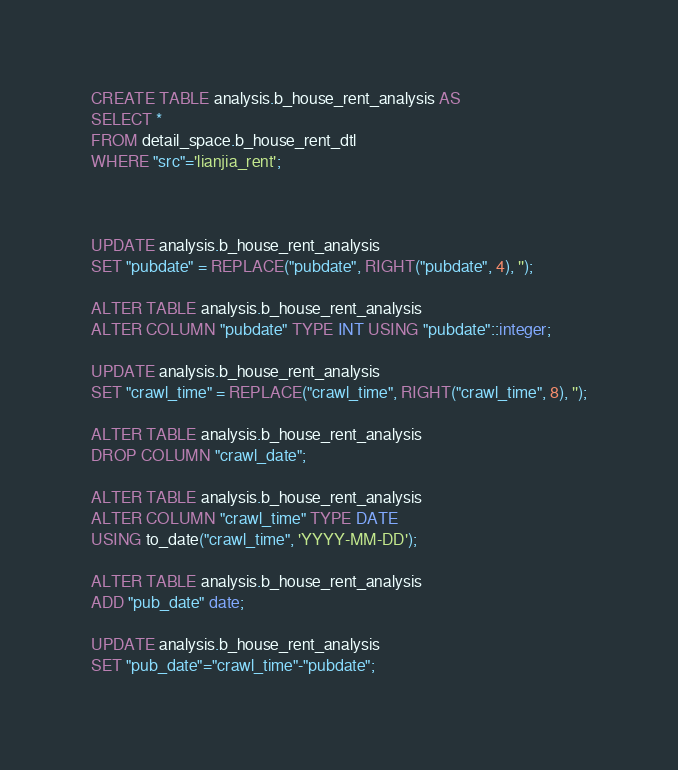Convert code to text. <code><loc_0><loc_0><loc_500><loc_500><_SQL_>CREATE TABLE analysis.b_house_rent_analysis AS 
SELECT *
FROM detail_space.b_house_rent_dtl
WHERE "src"='lianjia_rent';



UPDATE analysis.b_house_rent_analysis
SET "pubdate" = REPLACE("pubdate", RIGHT("pubdate", 4), '');

ALTER TABLE analysis.b_house_rent_analysis
ALTER COLUMN "pubdate" TYPE INT USING "pubdate"::integer;

UPDATE analysis.b_house_rent_analysis
SET "crawl_time" = REPLACE("crawl_time", RIGHT("crawl_time", 8), '');

ALTER TABLE analysis.b_house_rent_analysis
DROP COLUMN "crawl_date";

ALTER TABLE analysis.b_house_rent_analysis
ALTER COLUMN "crawl_time" TYPE DATE
USING to_date("crawl_time", 'YYYY-MM-DD');

ALTER TABLE analysis.b_house_rent_analysis
ADD "pub_date" date;

UPDATE analysis.b_house_rent_analysis
SET "pub_date"="crawl_time"-"pubdate";</code> 